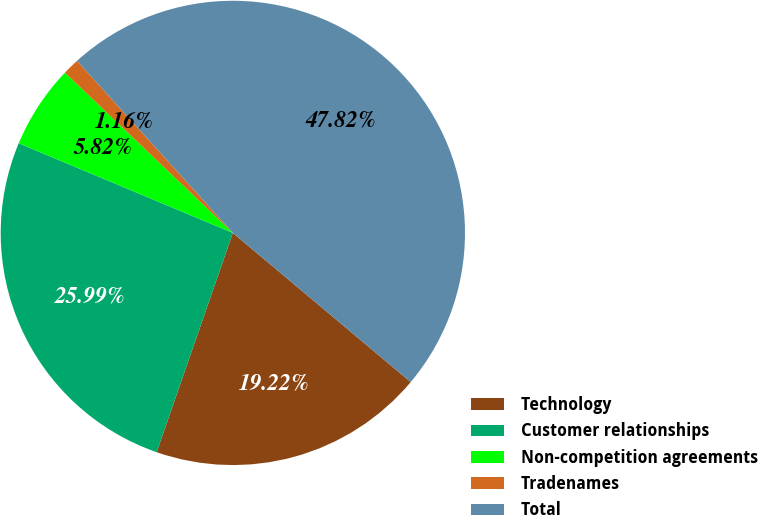<chart> <loc_0><loc_0><loc_500><loc_500><pie_chart><fcel>Technology<fcel>Customer relationships<fcel>Non-competition agreements<fcel>Tradenames<fcel>Total<nl><fcel>19.22%<fcel>25.99%<fcel>5.82%<fcel>1.16%<fcel>47.82%<nl></chart> 